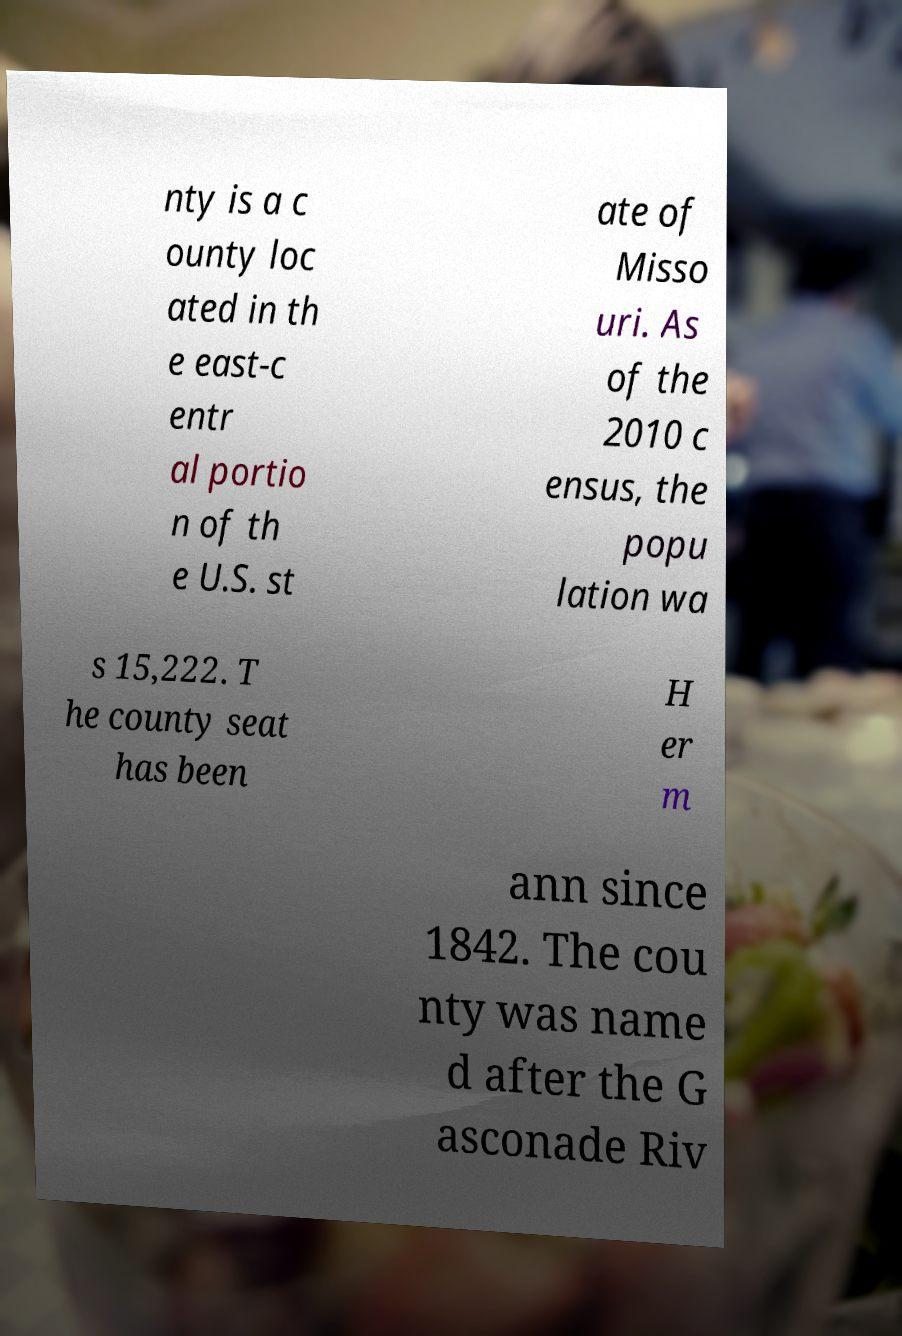I need the written content from this picture converted into text. Can you do that? nty is a c ounty loc ated in th e east-c entr al portio n of th e U.S. st ate of Misso uri. As of the 2010 c ensus, the popu lation wa s 15,222. T he county seat has been H er m ann since 1842. The cou nty was name d after the G asconade Riv 